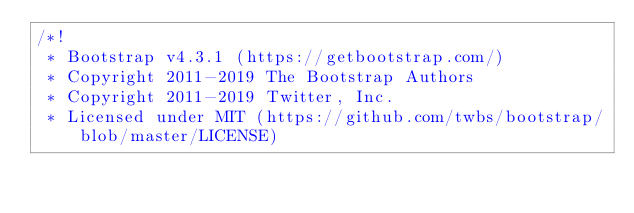<code> <loc_0><loc_0><loc_500><loc_500><_CSS_>/*!
 * Bootstrap v4.3.1 (https://getbootstrap.com/)
 * Copyright 2011-2019 The Bootstrap Authors
 * Copyright 2011-2019 Twitter, Inc.
 * Licensed under MIT (https://github.com/twbs/bootstrap/blob/master/LICENSE)</code> 